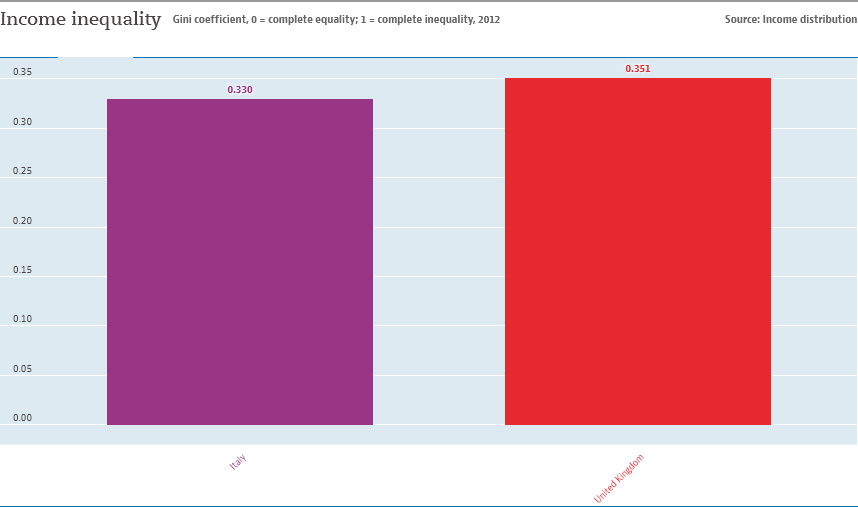Draw attention to some important aspects in this diagram. The value of the United Kingdom is 0.021 and the value of Italy is 0.021. There are two bars in the chart. 